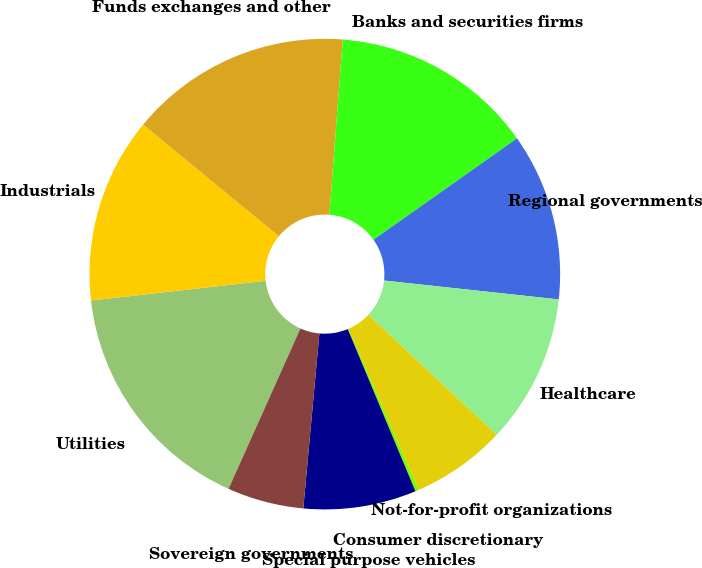<chart> <loc_0><loc_0><loc_500><loc_500><pie_chart><fcel>Utilities<fcel>Industrials<fcel>Funds exchanges and other<fcel>Banks and securities firms<fcel>Regional governments<fcel>Healthcare<fcel>Not-for-profit organizations<fcel>Consumer discretionary<fcel>Special purpose vehicles<fcel>Sovereign governments<nl><fcel>16.5%<fcel>12.75%<fcel>15.25%<fcel>14.0%<fcel>11.5%<fcel>10.25%<fcel>6.5%<fcel>0.24%<fcel>7.75%<fcel>5.25%<nl></chart> 